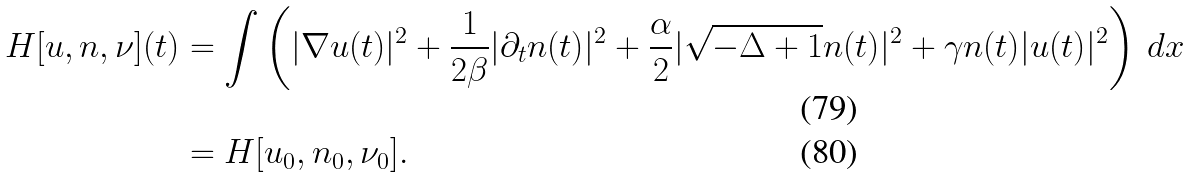Convert formula to latex. <formula><loc_0><loc_0><loc_500><loc_500>H [ u , n , \nu ] ( t ) & = \int \left ( | \nabla u ( t ) | ^ { 2 } + \frac { 1 } { 2 \beta } | \partial _ { t } n ( t ) | ^ { 2 } + \frac { \alpha } { 2 } | \sqrt { - \Delta + 1 } n ( t ) | ^ { 2 } + \gamma n ( t ) | u ( t ) | ^ { 2 } \right ) \, d x \\ & = H [ u _ { 0 } , n _ { 0 } , \nu _ { 0 } ] .</formula> 